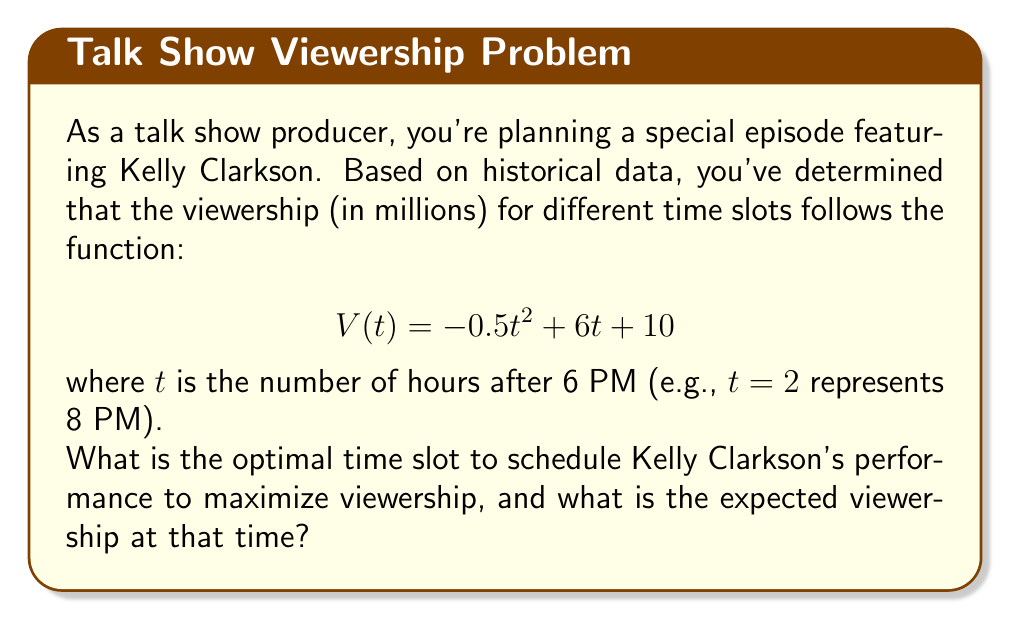Solve this math problem. To solve this problem, we need to find the maximum value of the viewership function $V(t)$. This can be done by following these steps:

1) The function $V(t) = -0.5t^2 + 6t + 10$ is a quadratic function, which forms a parabola when graphed. The maximum point of a parabola occurs at its vertex.

2) For a quadratic function in the form $f(t) = at^2 + bt + c$, the t-coordinate of the vertex is given by $t = -\frac{b}{2a}$.

3) In our function, $a = -0.5$ and $b = 6$. Let's substitute these values:

   $$t = -\frac{6}{2(-0.5)} = -\frac{6}{-1} = 6$$

4) This means the viewership is maximized 6 hours after 6 PM, which is 12 AM (midnight).

5) To find the maximum viewership, we substitute $t = 6$ into our original function:

   $$V(6) = -0.5(6)^2 + 6(6) + 10$$
   $$= -0.5(36) + 36 + 10$$
   $$= -18 + 36 + 10$$
   $$= 28$$

Therefore, the optimal time slot is 12 AM (midnight), and the expected viewership at that time is 28 million viewers.
Answer: The optimal time slot is 12 AM (midnight), with an expected viewership of 28 million viewers. 